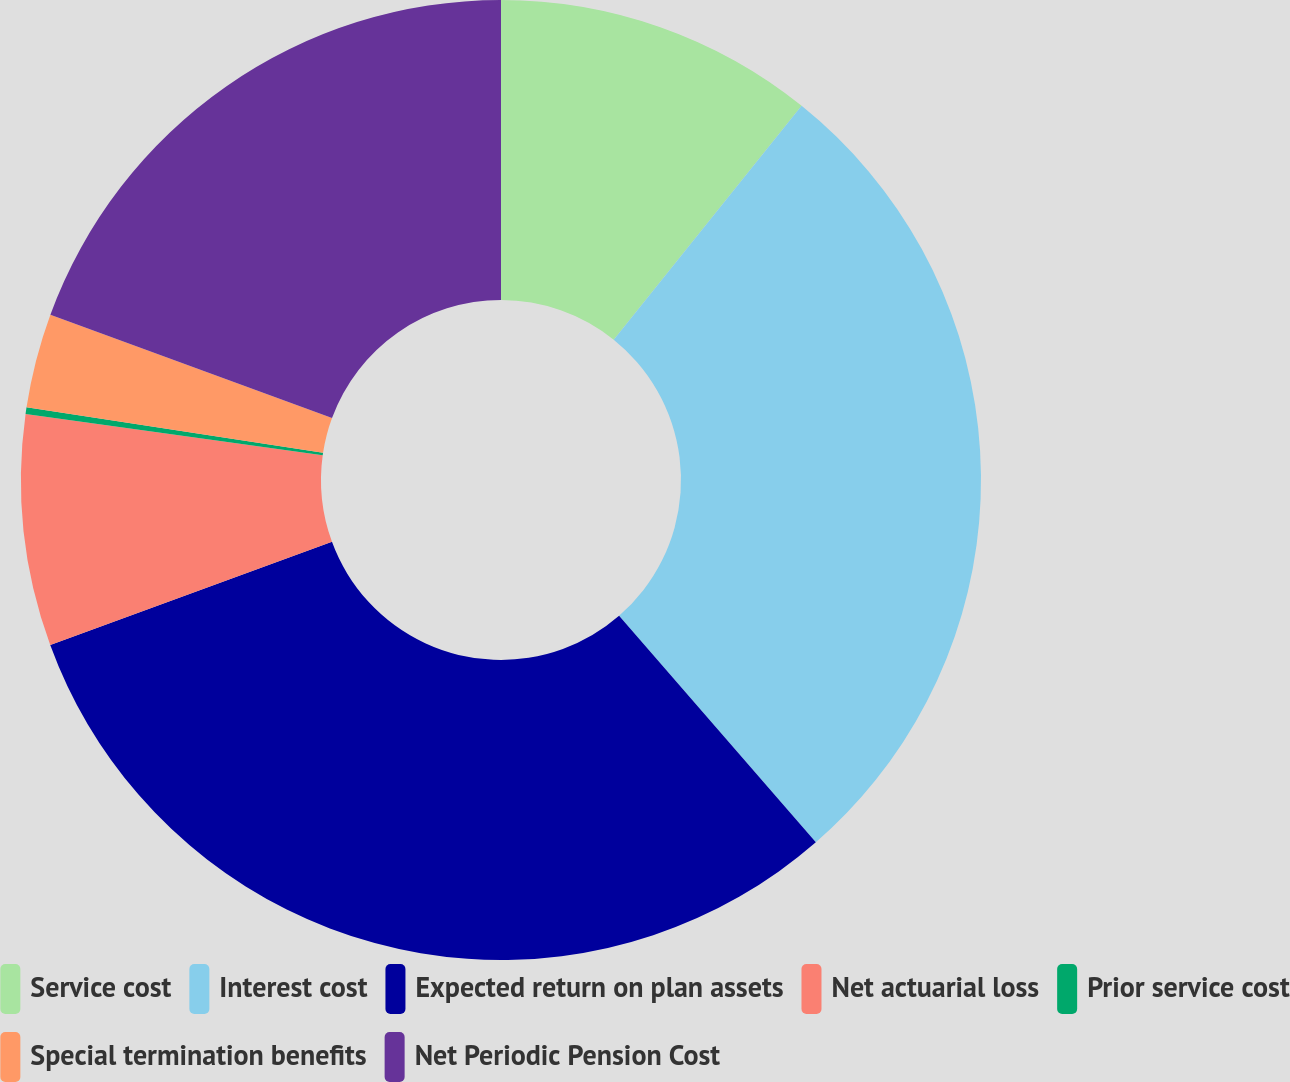Convert chart to OTSL. <chart><loc_0><loc_0><loc_500><loc_500><pie_chart><fcel>Service cost<fcel>Interest cost<fcel>Expected return on plan assets<fcel>Net actuarial loss<fcel>Prior service cost<fcel>Special termination benefits<fcel>Net Periodic Pension Cost<nl><fcel>10.77%<fcel>27.84%<fcel>30.8%<fcel>7.78%<fcel>0.22%<fcel>3.18%<fcel>19.4%<nl></chart> 